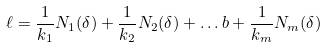Convert formula to latex. <formula><loc_0><loc_0><loc_500><loc_500>\ell = \frac { 1 } { k _ { 1 } } N _ { 1 } ( \delta ) + \frac { 1 } { k _ { 2 } } N _ { 2 } ( \delta ) + \dots b + \frac { 1 } { k _ { m } } N _ { m } ( \delta )</formula> 